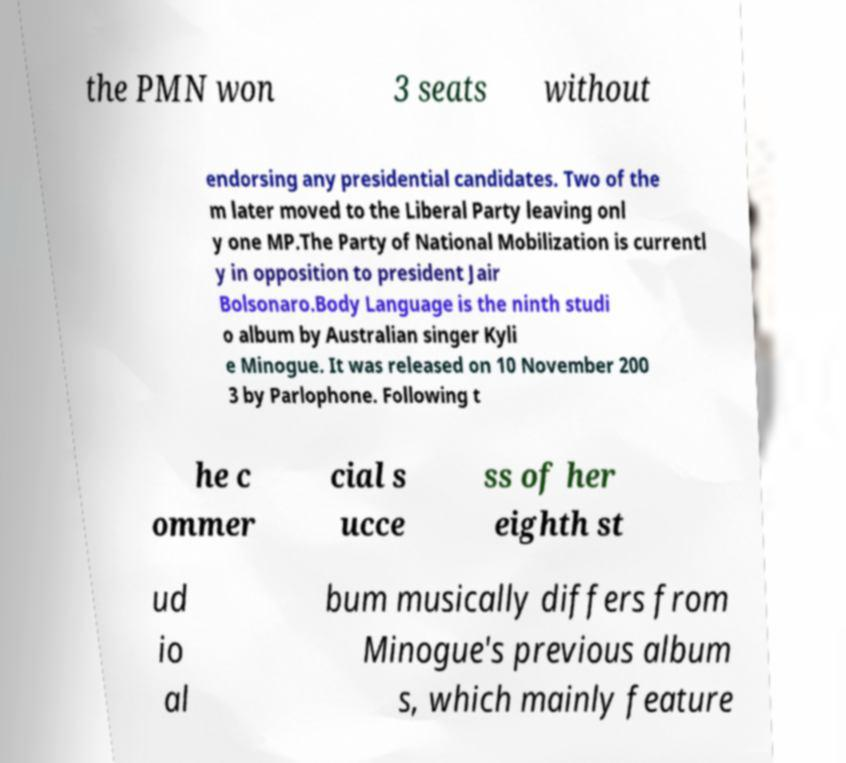Can you read and provide the text displayed in the image?This photo seems to have some interesting text. Can you extract and type it out for me? the PMN won 3 seats without endorsing any presidential candidates. Two of the m later moved to the Liberal Party leaving onl y one MP.The Party of National Mobilization is currentl y in opposition to president Jair Bolsonaro.Body Language is the ninth studi o album by Australian singer Kyli e Minogue. It was released on 10 November 200 3 by Parlophone. Following t he c ommer cial s ucce ss of her eighth st ud io al bum musically differs from Minogue's previous album s, which mainly feature 